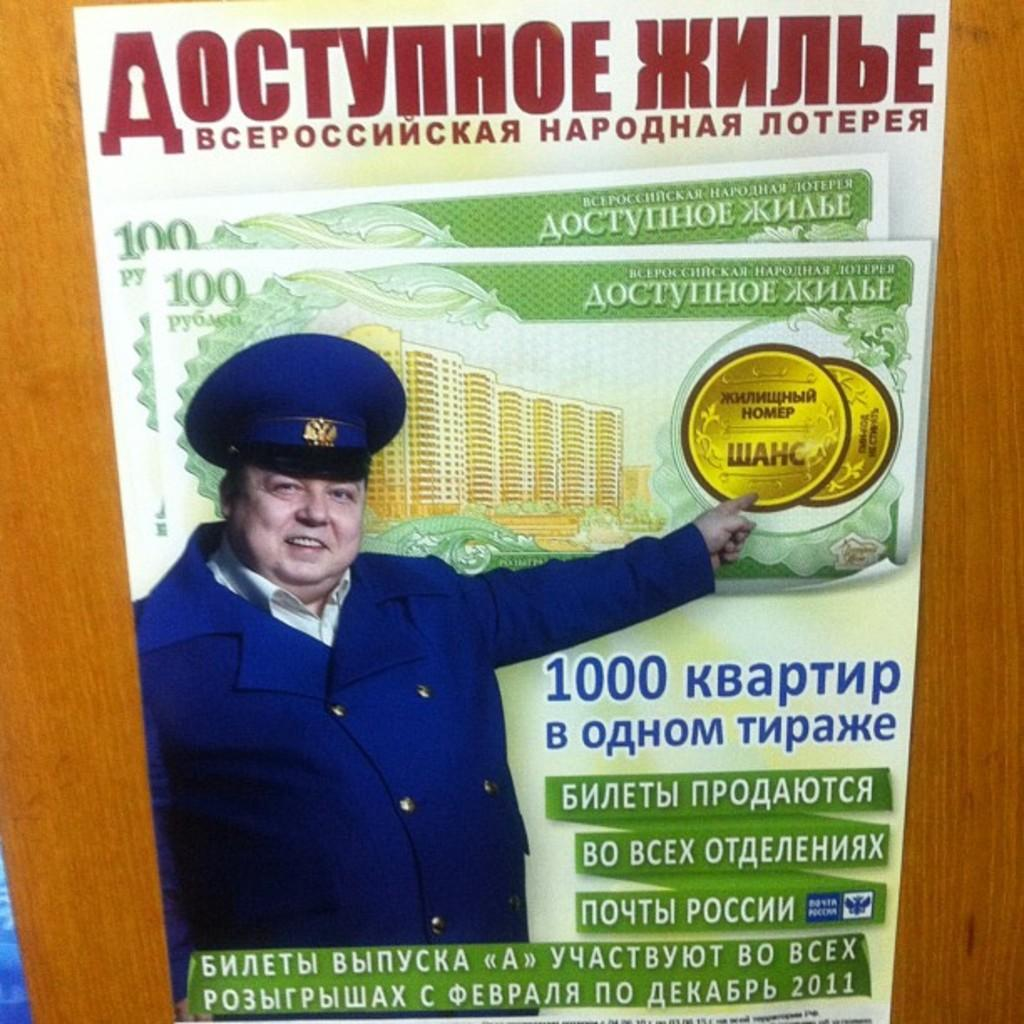What is located in the foreground of the image? There is a poster in the foreground of the image. What is the poster placed on? The poster is on a wooden surface. What can be found on the poster? There is text, a building, and a person depicted on the poster. Are there any objects or symbols on the poster? Yes, there are coins depicted on the poster. What type of mouth can be seen on the person depicted on the poster? There is no mouth visible on the person depicted on the poster. How does the coil move around in the image? There is no coil present in the image. 